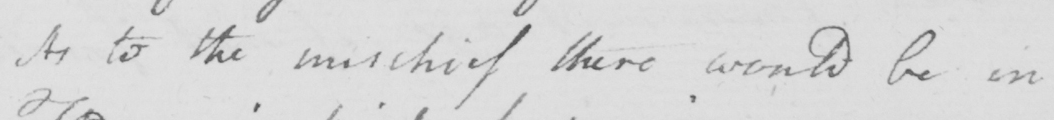What text is written in this handwritten line? As to the mischief there would be in 